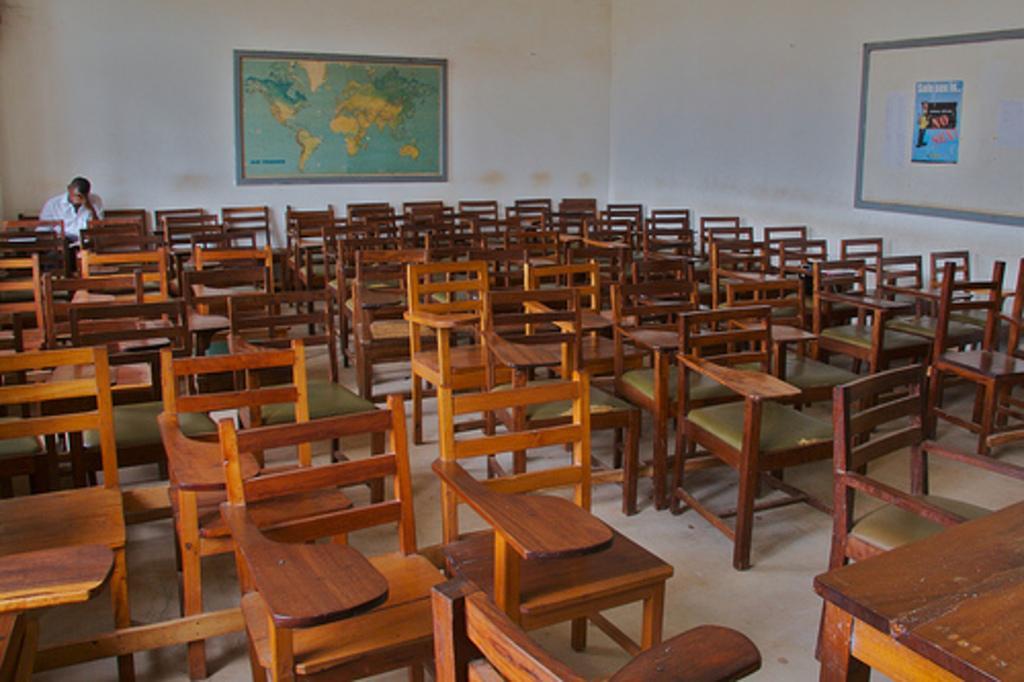In one or two sentences, can you explain what this image depicts? This is the picture of a room in which there are some chairs and a person who is sitting and also we can see a board and a poster to the wall. 